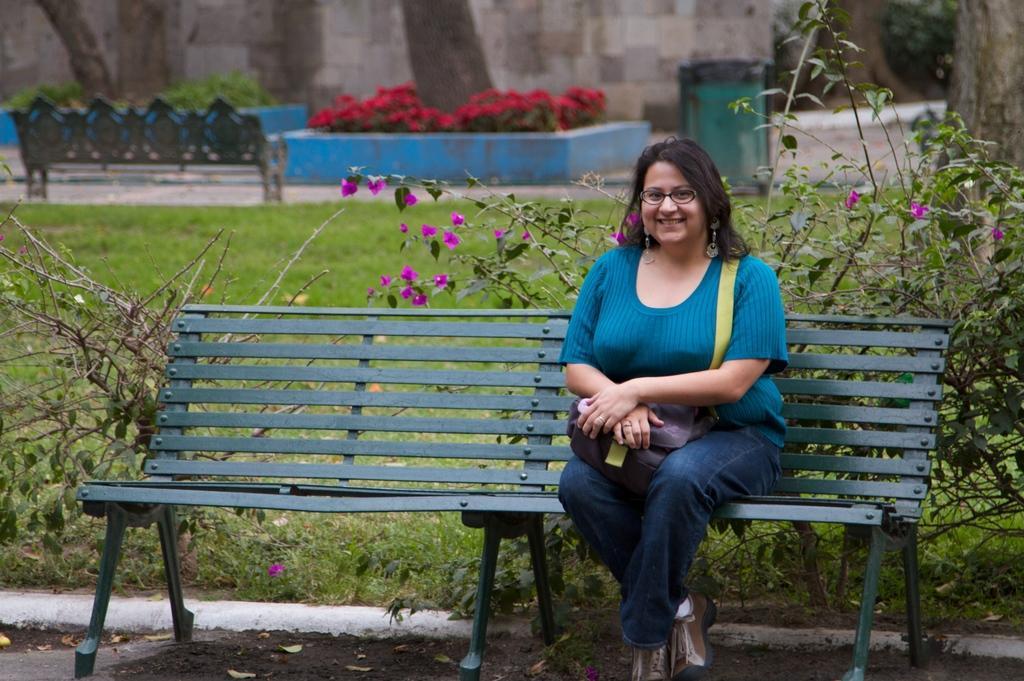Can you describe this image briefly? In the picture I can see a woman sitting on the metal bench and there is a smile on her face. She is wearing a blue color top and she is holding a bag. I can see another metal bench on the top left side. I can see the trunk of a tree on the top right side. In the background, I can see the flowering plants and green grass. 